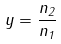Convert formula to latex. <formula><loc_0><loc_0><loc_500><loc_500>y = \frac { n _ { 2 } } { n _ { 1 } }</formula> 